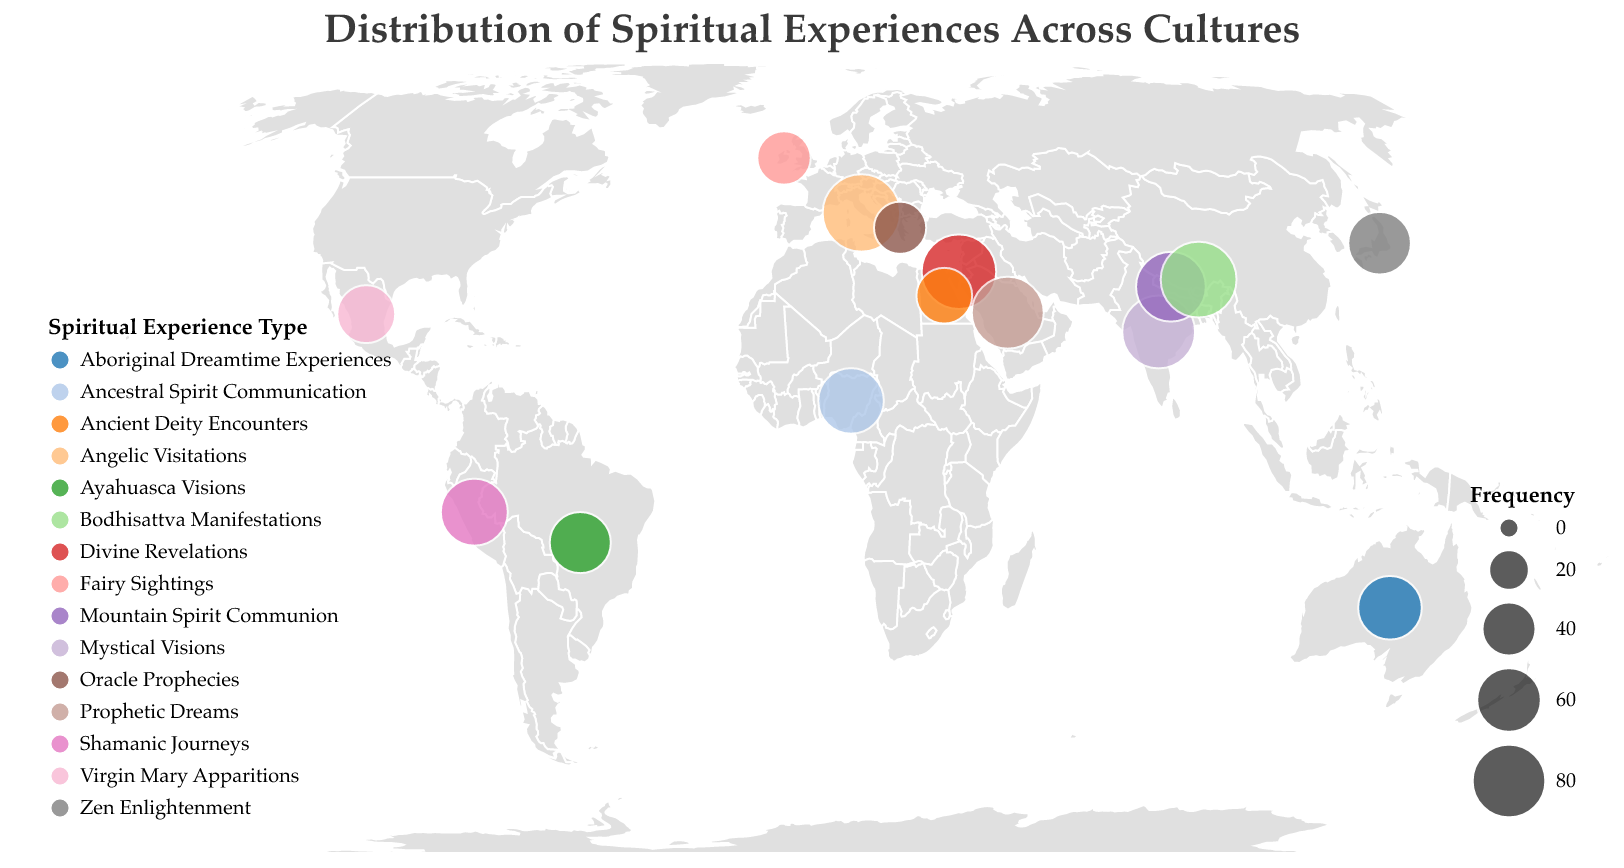What is the title of the plot? The plot's title is located at the top of the chart and describes what the visualization is about.
Answer: Distribution of Spiritual Experiences Across Cultures How many countries are represented in the plot? By looking at the number of data points (each point representing a country), you can count the total number of different countries. There are 15 unique countries listed in the data.
Answer: 15 Which country has the highest frequency of spiritual experiences? The frequency can be visually identified by the size of the circles. The largest circle in the dataset represents Vatican City with a frequency of 89.
Answer: Vatican City Compare the frequency of spiritual experiences in Nepal and Nigeria. Which country has a higher frequency, and by how much? The plot shows Nepal with a frequency of 71 and Nigeria with a frequency of 62. Subtract Nigeria's frequency from Nepal's frequency (71 - 62 = 9).
Answer: Nepal by 9 What type of spiritual experience is most frequently reported in Israel? The legend provides information linking colors to spiritual experience types. The tooltip reveals specific data points by hovering over Israel, showing that Divine Revelations are the most frequently reported type with a frequency of 82.
Answer: Divine Revelations Which two countries report the closest frequency in spiritual experiences? By comparing the circle sizes and checking the precise values with the tooltip, you find that Egypt (43) and Mexico (47) have the closest frequencies with a difference of 4.
Answer: Egypt and Mexico What is the median frequency of the spiritual experiences reported across all countries? To find the median, list all frequencies (78, 65, 82, 56, 43, 39, 71, 58, 47, 89, 85, 62, 53, 37, 76) and sort them (37, 39, 43, 47, 53, 56, 58, 62, 65, 71, 76, 78, 82, 85, 89). The median is the middle value which is 62.
Answer: 62 Which spiritual experience has the highest collective frequency among the countries? Look at all reported frequencies for each type and sum them up. Divine Revelations in Israel (82) and Angelic Visitations in Vatican City (89) are the highest; comparing, Angelic Visitations with a frequency of 89 is the highest individual count.
Answer: Angelic Visitations What cultural group is associated with the reported spiritual experiences in Peru based on the plot legend and tooltip? Hover over Peru to find that the spiritual experiences reported are Shamanic Journeys.
Answer: Shamanic Journeys 